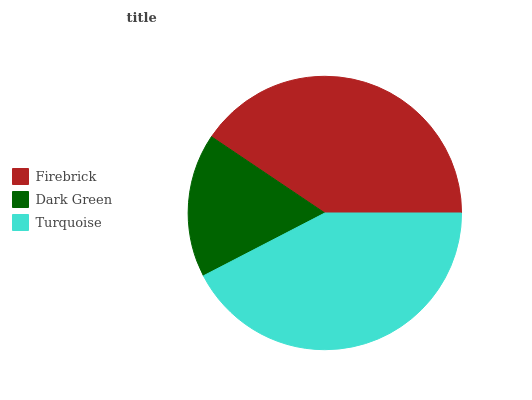Is Dark Green the minimum?
Answer yes or no. Yes. Is Turquoise the maximum?
Answer yes or no. Yes. Is Turquoise the minimum?
Answer yes or no. No. Is Dark Green the maximum?
Answer yes or no. No. Is Turquoise greater than Dark Green?
Answer yes or no. Yes. Is Dark Green less than Turquoise?
Answer yes or no. Yes. Is Dark Green greater than Turquoise?
Answer yes or no. No. Is Turquoise less than Dark Green?
Answer yes or no. No. Is Firebrick the high median?
Answer yes or no. Yes. Is Firebrick the low median?
Answer yes or no. Yes. Is Turquoise the high median?
Answer yes or no. No. Is Dark Green the low median?
Answer yes or no. No. 